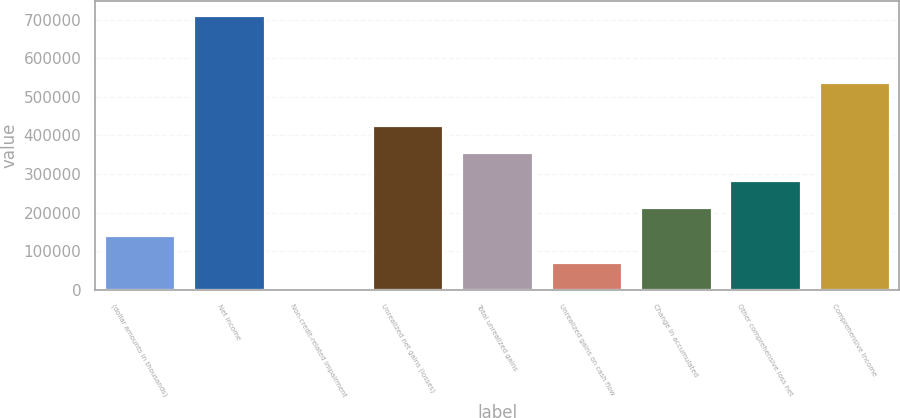Convert chart to OTSL. <chart><loc_0><loc_0><loc_500><loc_500><bar_chart><fcel>(dollar amounts in thousands)<fcel>Net income<fcel>Non-credit-related impairment<fcel>Unrealized net gains (losses)<fcel>Total unrealized gains<fcel>Unrealized gains on cash flow<fcel>Change in accumulated<fcel>Other comprehensive loss net<fcel>Comprehensive income<nl><fcel>142832<fcel>711821<fcel>585<fcel>427327<fcel>356203<fcel>71708.6<fcel>213956<fcel>285079<fcel>536963<nl></chart> 